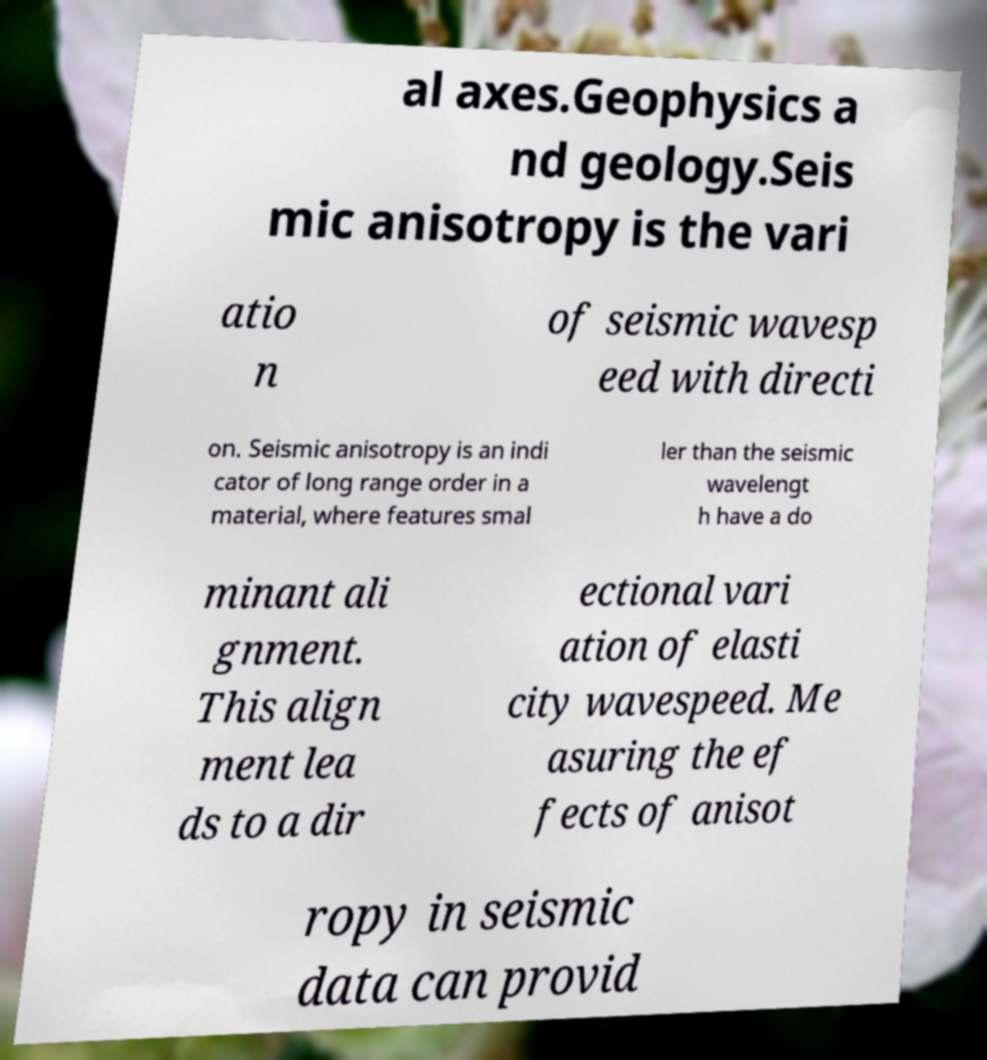Could you assist in decoding the text presented in this image and type it out clearly? al axes.Geophysics a nd geology.Seis mic anisotropy is the vari atio n of seismic wavesp eed with directi on. Seismic anisotropy is an indi cator of long range order in a material, where features smal ler than the seismic wavelengt h have a do minant ali gnment. This align ment lea ds to a dir ectional vari ation of elasti city wavespeed. Me asuring the ef fects of anisot ropy in seismic data can provid 